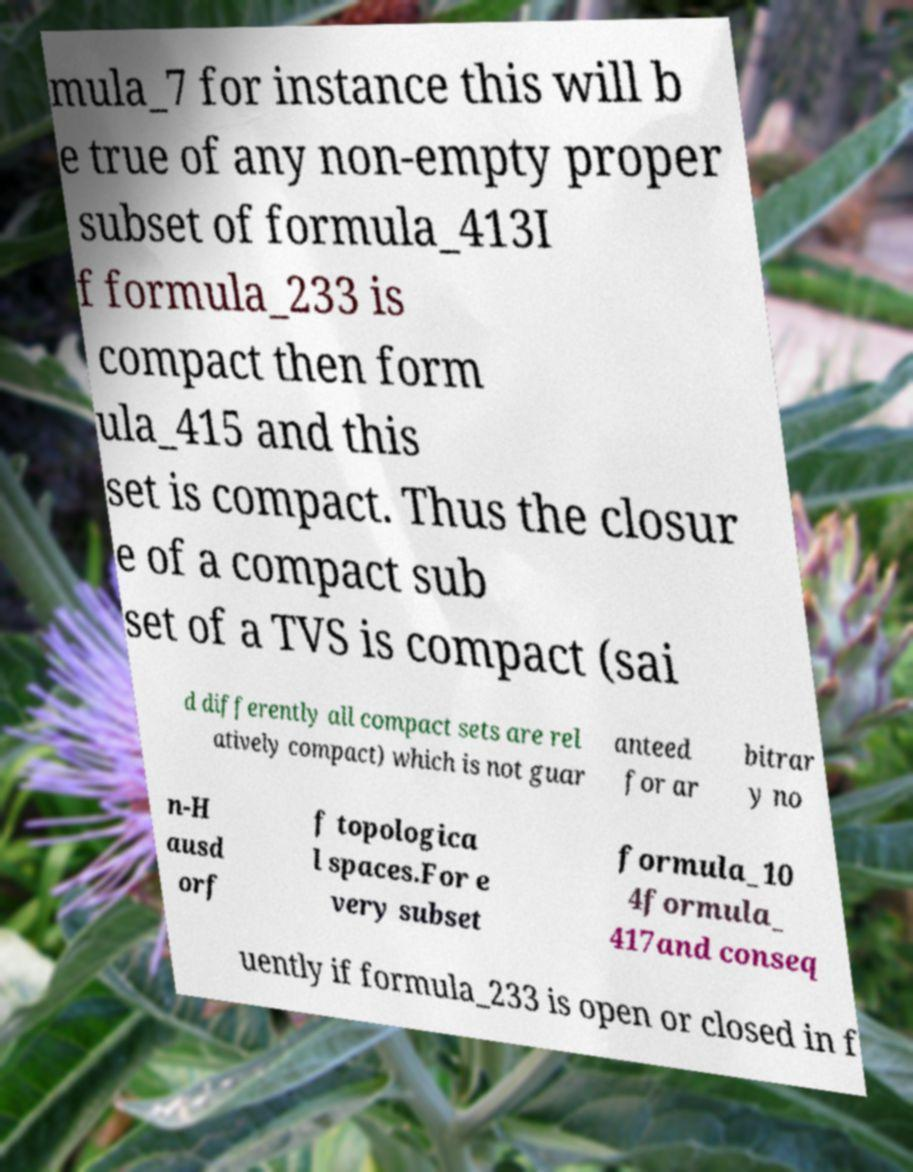What messages or text are displayed in this image? I need them in a readable, typed format. mula_7 for instance this will b e true of any non-empty proper subset of formula_413I f formula_233 is compact then form ula_415 and this set is compact. Thus the closur e of a compact sub set of a TVS is compact (sai d differently all compact sets are rel atively compact) which is not guar anteed for ar bitrar y no n-H ausd orf f topologica l spaces.For e very subset formula_10 4formula_ 417and conseq uently if formula_233 is open or closed in f 